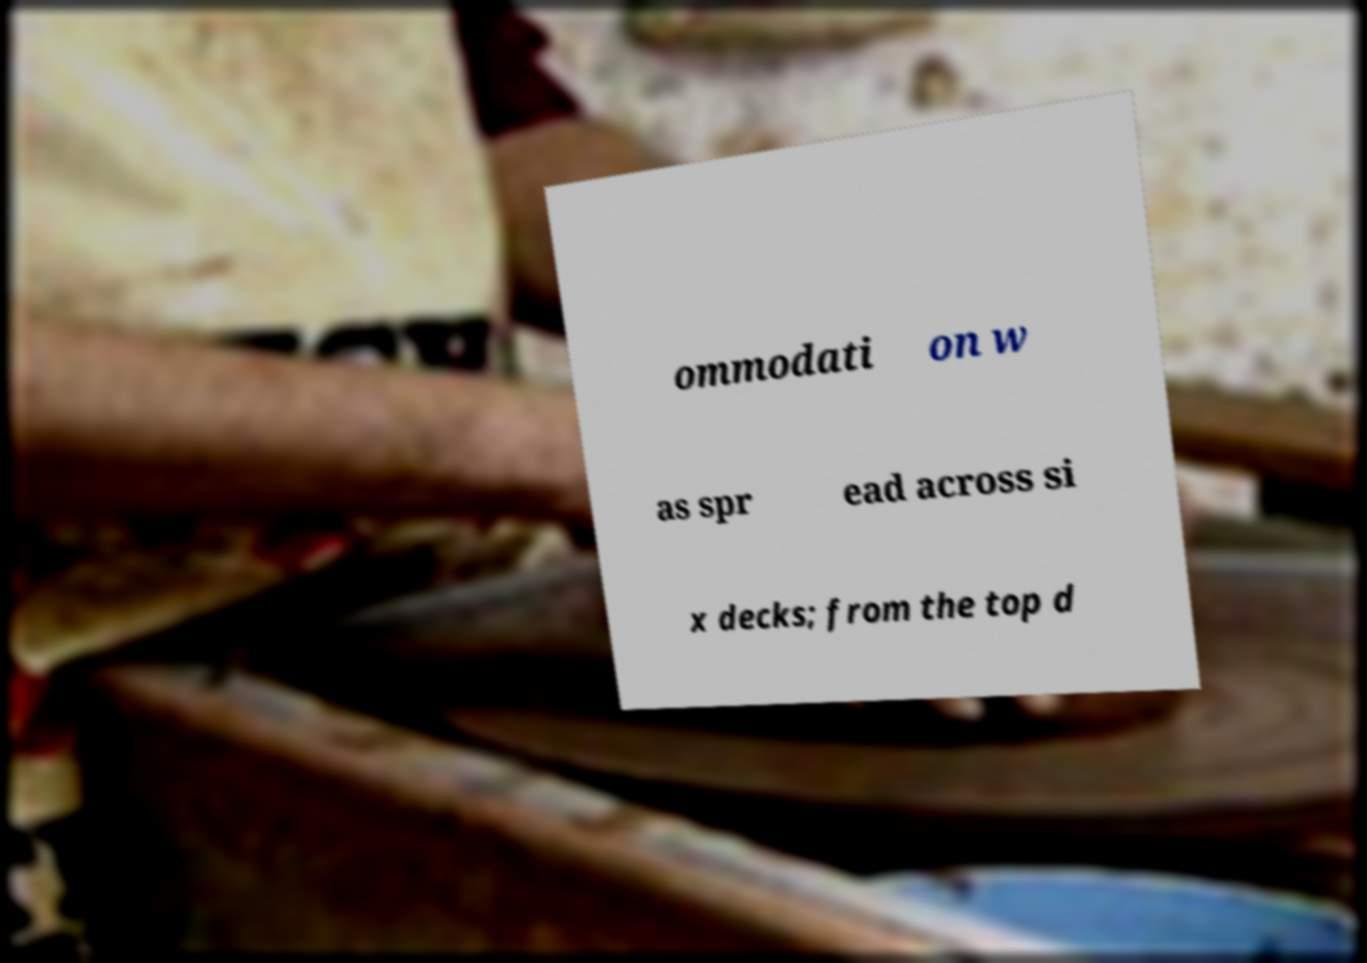Can you read and provide the text displayed in the image?This photo seems to have some interesting text. Can you extract and type it out for me? ommodati on w as spr ead across si x decks; from the top d 